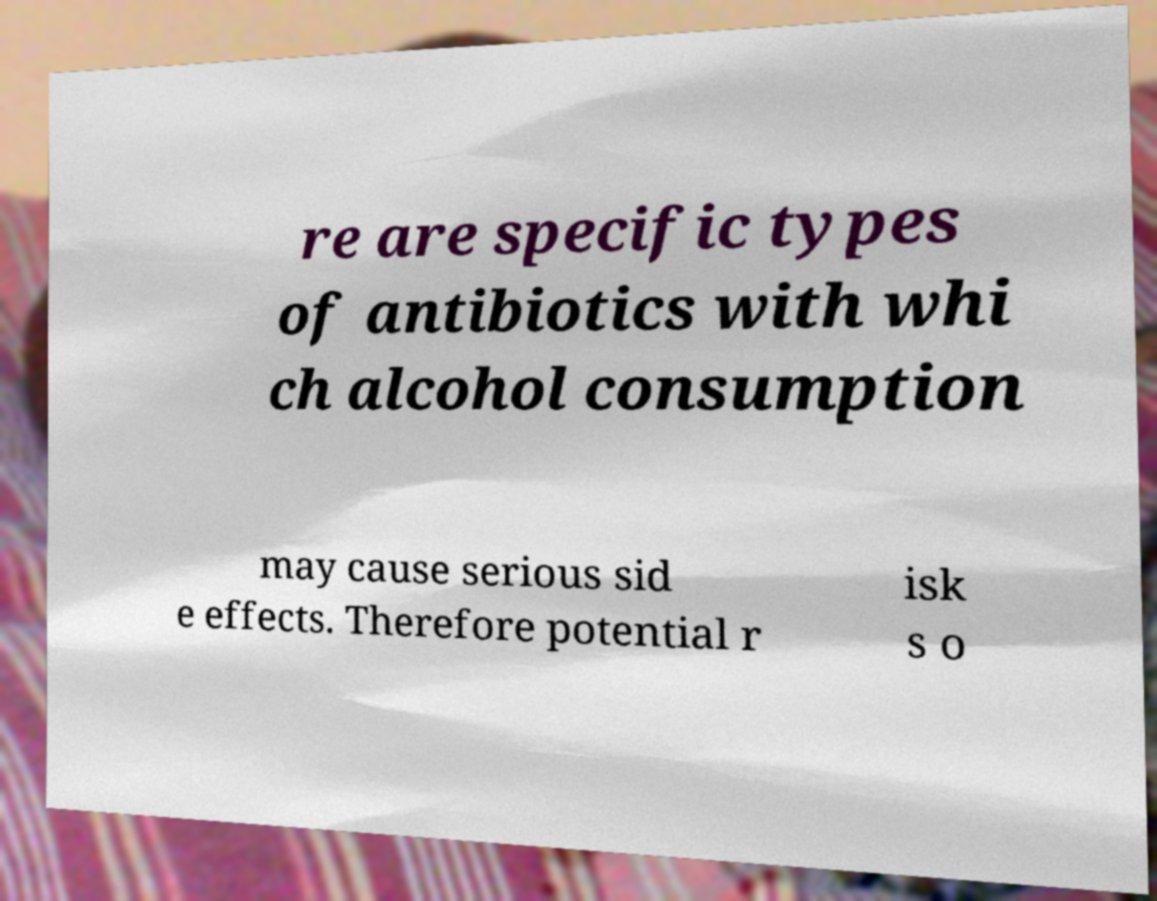Could you assist in decoding the text presented in this image and type it out clearly? re are specific types of antibiotics with whi ch alcohol consumption may cause serious sid e effects. Therefore potential r isk s o 